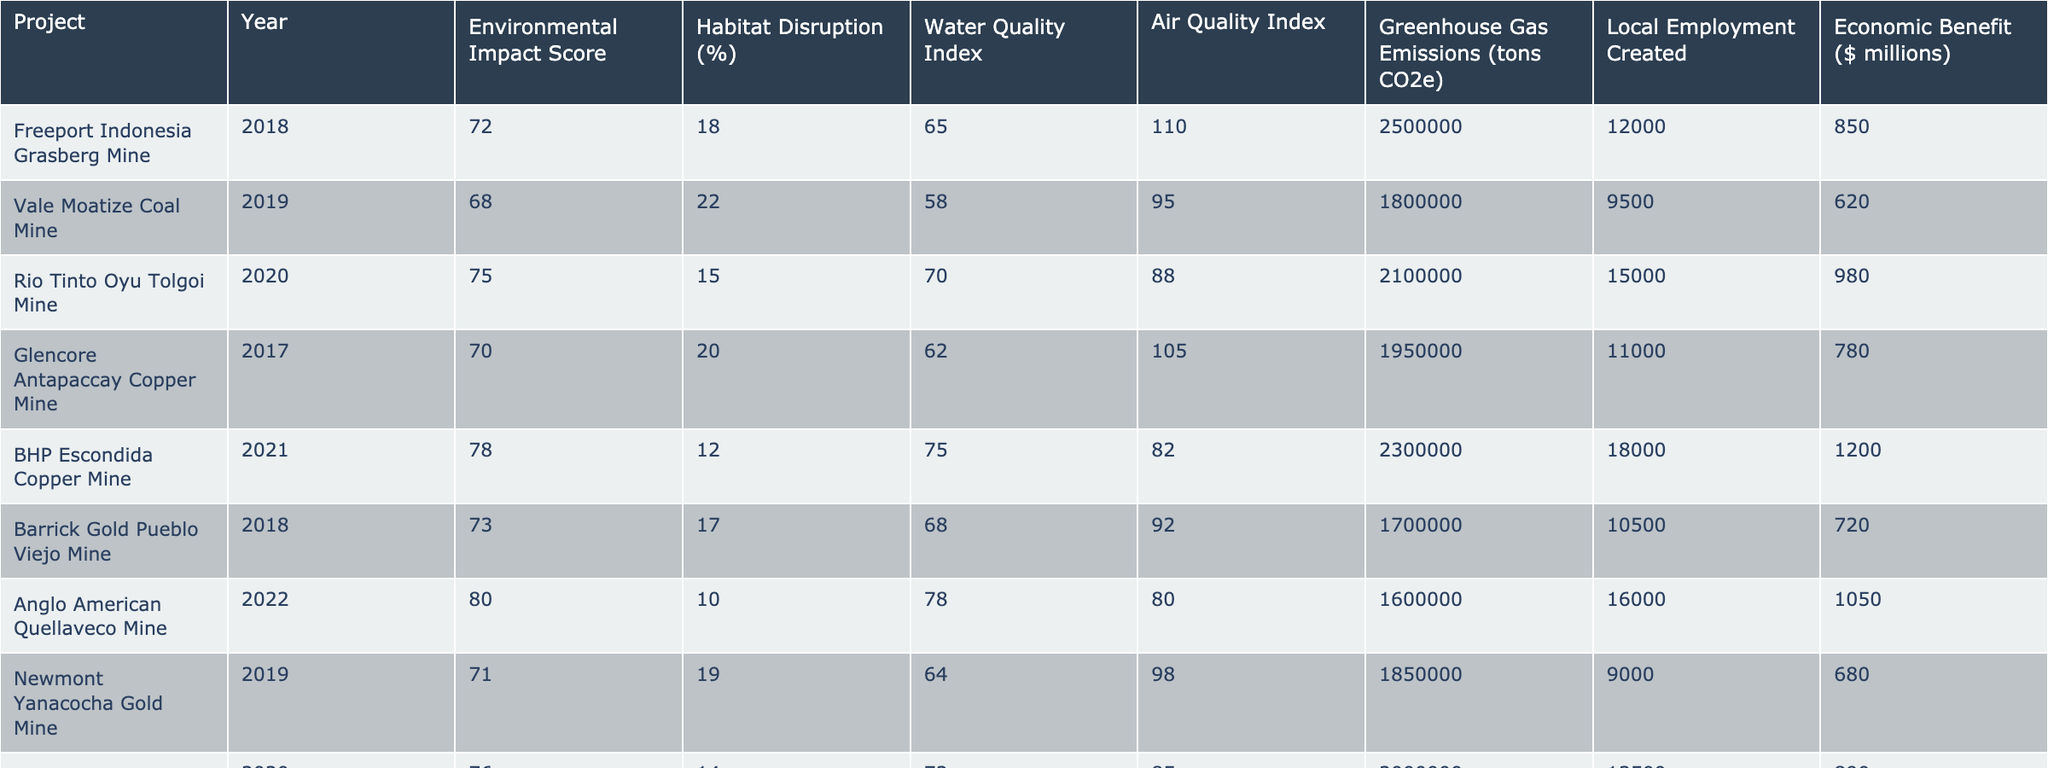What is the Environmental Impact Score for the BHP Escondida Copper Mine? The Environmental Impact Score for the BHP Escondida Copper Mine is directly listed in the table. It shows a score of 78 in the year 2021.
Answer: 78 What percentage of habitat disruption is associated with the Vale Moatize Coal Mine? The percentage of habitat disruption for the Vale Moatize Coal Mine is found in the table under "Habitat Disruption (%)", which indicates it is 22%.
Answer: 22% Which mining project had the highest Water Quality Index and what was the value? By looking at the Water Quality Index column, the highest value of 78 belongs to the Anglo American Quellaveco Mine in 2022.
Answer: 78 What is the average Greenhouse Gas Emissions (tons CO2e) of all listed mining operations? To find the average, we sum the emissions for all projects (2500000 + 1800000 + 2100000 + 1950000 + 2300000 + 1700000 + 1600000 + 1850000 + 2000000 + 1750000 = 20750000) and divide by the number of projects (10), resulting in an average of 2075000 tons CO2e.
Answer: 2075000 Does the Glencore Antapaccay Copper Mine have a higher Air Quality Index than the local employment created? The Glencore Antapaccay Copper Mine has an Air Quality Index of 105 and local employment created is 11000. Since 105 is less than 11000 the statement is false.
Answer: No Which project created the most local employment, and how many jobs were created? The project that created the most local employment is the BHP Escondida Copper Mine, with 18000 jobs created in 2021.
Answer: 18000 What is the difference in Economic Benefit ($ millions) between the Freeport Indonesia Grasberg Mine and the BHP Escondida Copper Mine? The economic benefit for Freeport Indonesia Grasberg Mine is 850 million and for BHP Escondida Copper Mine, it is 1200 million. Subtracting these gives 1200 - 850 = 350 million.
Answer: 350 Is the Environmental Impact Score of the Rio Tinto Oyu Tolgoi Mine higher than that of the Newmont Yanacocha Gold Mine? The Environmental Impact Score for Rio Tinto Oyu Tolgoi Mine is 75, while for Newmont Yanacocha Gold Mine it is 71. Since 75 > 71, the statement is true.
Answer: Yes What is the lowest Water Quality Index recorded among the mining projects? By inspecting the Water Quality Index column, the lowest value of 58 is associated with the Vale Moatize Coal Mine in 2019.
Answer: 58 Which two mining projects have the least Habitat Disruption percentages, and what are those percentages? Looking at the Habitat Disruption (%) column, the least percentages are 10% for Anglo American Quellaveco Mine and 12% for BHP Escondida Copper Mine.
Answer: 10% and 12% 